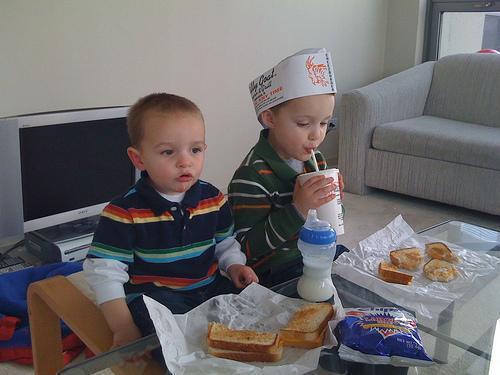What is the source of the melted product is in the center of sandwiches shown?
Make your selection and explain in format: 'Answer: answer
Rationale: rationale.'
Options: Moose, yak, dog, cow. Answer: cow.
Rationale: We usually make cheese from their milk and this is a grilled cheese sandwich. 